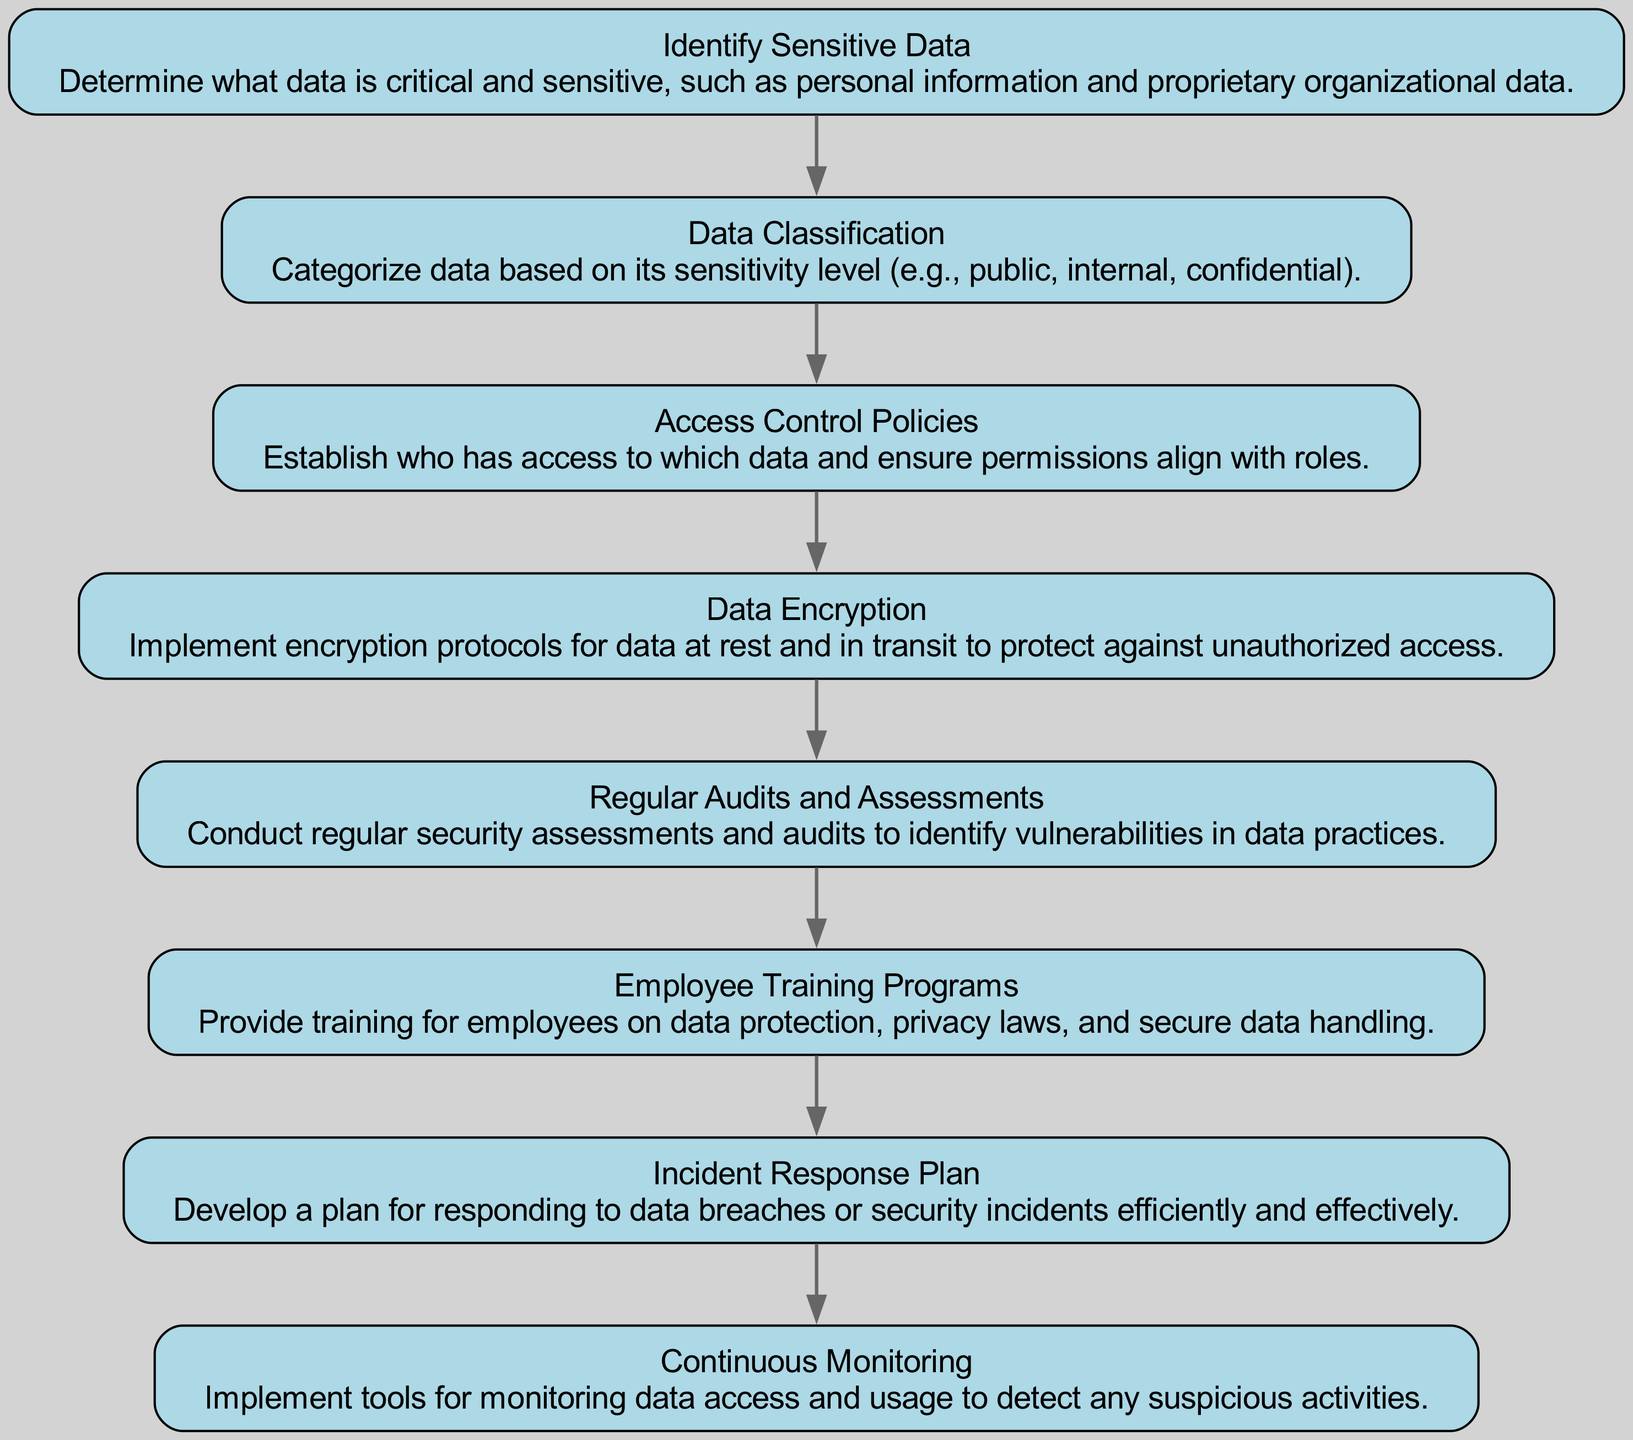What is the first step in implementing secure data practices? The first step in the flow chart is "Identify Sensitive Data," which is indicated as the initial node. This means it is the starting point for the secure data practices implementation process.
Answer: Identify Sensitive Data How many nodes are there in the diagram? The diagram has eight nodes representing different steps in implementing secure data practices. Each node corresponds to a specific action or policy in the flow.
Answer: Eight What follows "Data Classification" in the flow? After "Data Classification," the next step in the flow is "Access Control Policies." This can be deduced by looking for the direct relationship between these two nodes in the diagram.
Answer: Access Control Policies Which step emphasizes the importance of monitoring? The step that emphasizes monitoring is "Continuous Monitoring." This step indicates the need to implement tools to detect suspicious activities related to data access.
Answer: Continuous Monitoring What is the relationship between "Data Encryption" and "Regular Audits and Assessments"? "Data Encryption" is followed by "Regular Audits and Assessments," indicating a sequential relationship where encryption efforts are likely assessed through regular audits.
Answer: Sequential What is the final step in the diagram? The final step in the flow chart is "Incident Response Plan," which represents the final action taken after implementing the other secure data practices.
Answer: Incident Response Plan Name a key component of employee training programs shown in the diagram. A key component is "data protection," as it focuses on educating employees regarding secure data handling practices during the training.
Answer: Data protection Which action is necessary for data at rest and in transit? The necessary action for data at rest and in transit is "Data Encryption," indicating that encryption protocols should be applied to protect data in both states.
Answer: Data Encryption 